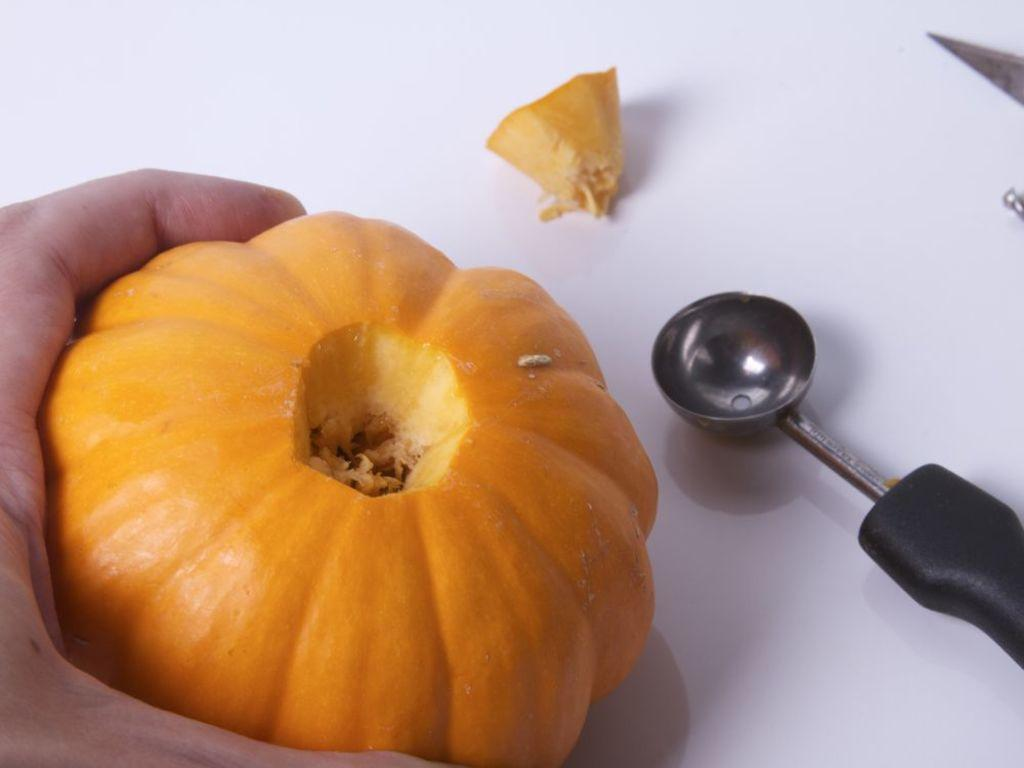What utensil can be seen in the image? There is a spoon in the image. What other utensil is present in the image? There is a knife in the image. What type of food is visible in the image? There is a piece of pumpkin in the image. Whose hand is visible in the image? A person's hand is visible in the image. What is the person's hand holding? The person's hand is holding a pumpkin. On what surface are the objects placed? The objects are on a surface. How many kittens are sitting on the pumpkin in the image? There are no kittens present in the image. What is the reason behind the person holding the pumpkin in the image? The image does not provide any information about the reason behind the person holding the pumpkin. 